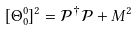Convert formula to latex. <formula><loc_0><loc_0><loc_500><loc_500>[ \Theta _ { 0 } ^ { 0 } ] ^ { 2 } = \mathcal { P } ^ { \dagger } \mathcal { P } + M ^ { 2 }</formula> 